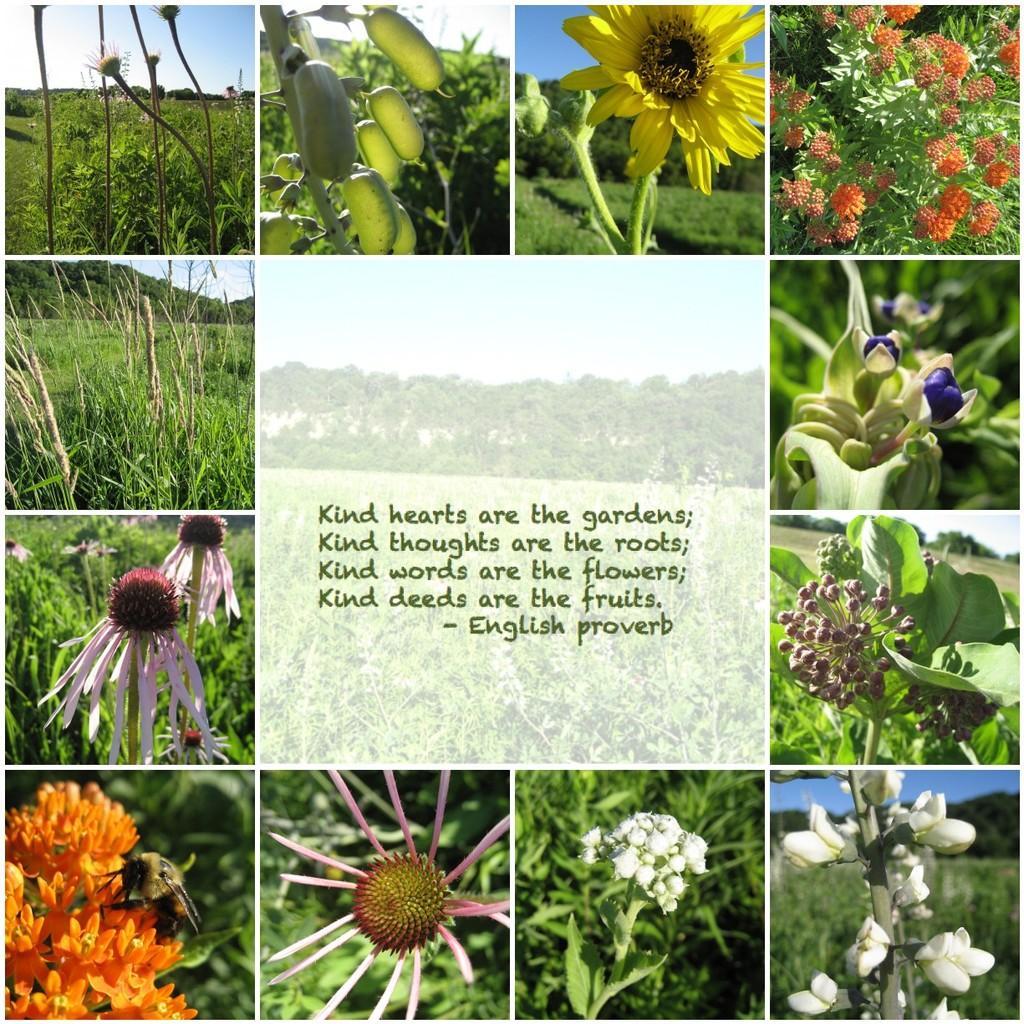Please provide a concise description of this image. In this image we can see collage pictures of plants and flowers. In the center of the image there is text. 